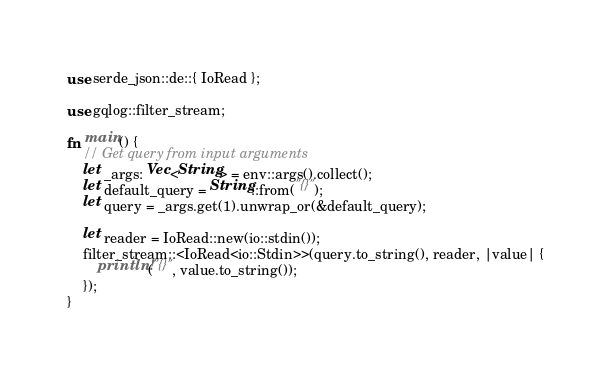Convert code to text. <code><loc_0><loc_0><loc_500><loc_500><_Rust_>use serde_json::de::{ IoRead };

use gqlog::filter_stream;

fn main() {
    // Get query from input arguments
    let _args: Vec<String> = env::args().collect();
    let default_query = String::from("{}");
    let query = _args.get(1).unwrap_or(&default_query);

    let reader = IoRead::new(io::stdin());
    filter_stream::<IoRead<io::Stdin>>(query.to_string(), reader, |value| {
        println!("{}", value.to_string());
    });
}
</code> 